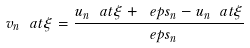Convert formula to latex. <formula><loc_0><loc_0><loc_500><loc_500>v _ { n } \ a t \xi = \frac { u _ { n } \ a t { \xi + \ e p s _ { n } } - u _ { n } \ a t \xi } { \ e p s _ { n } }</formula> 